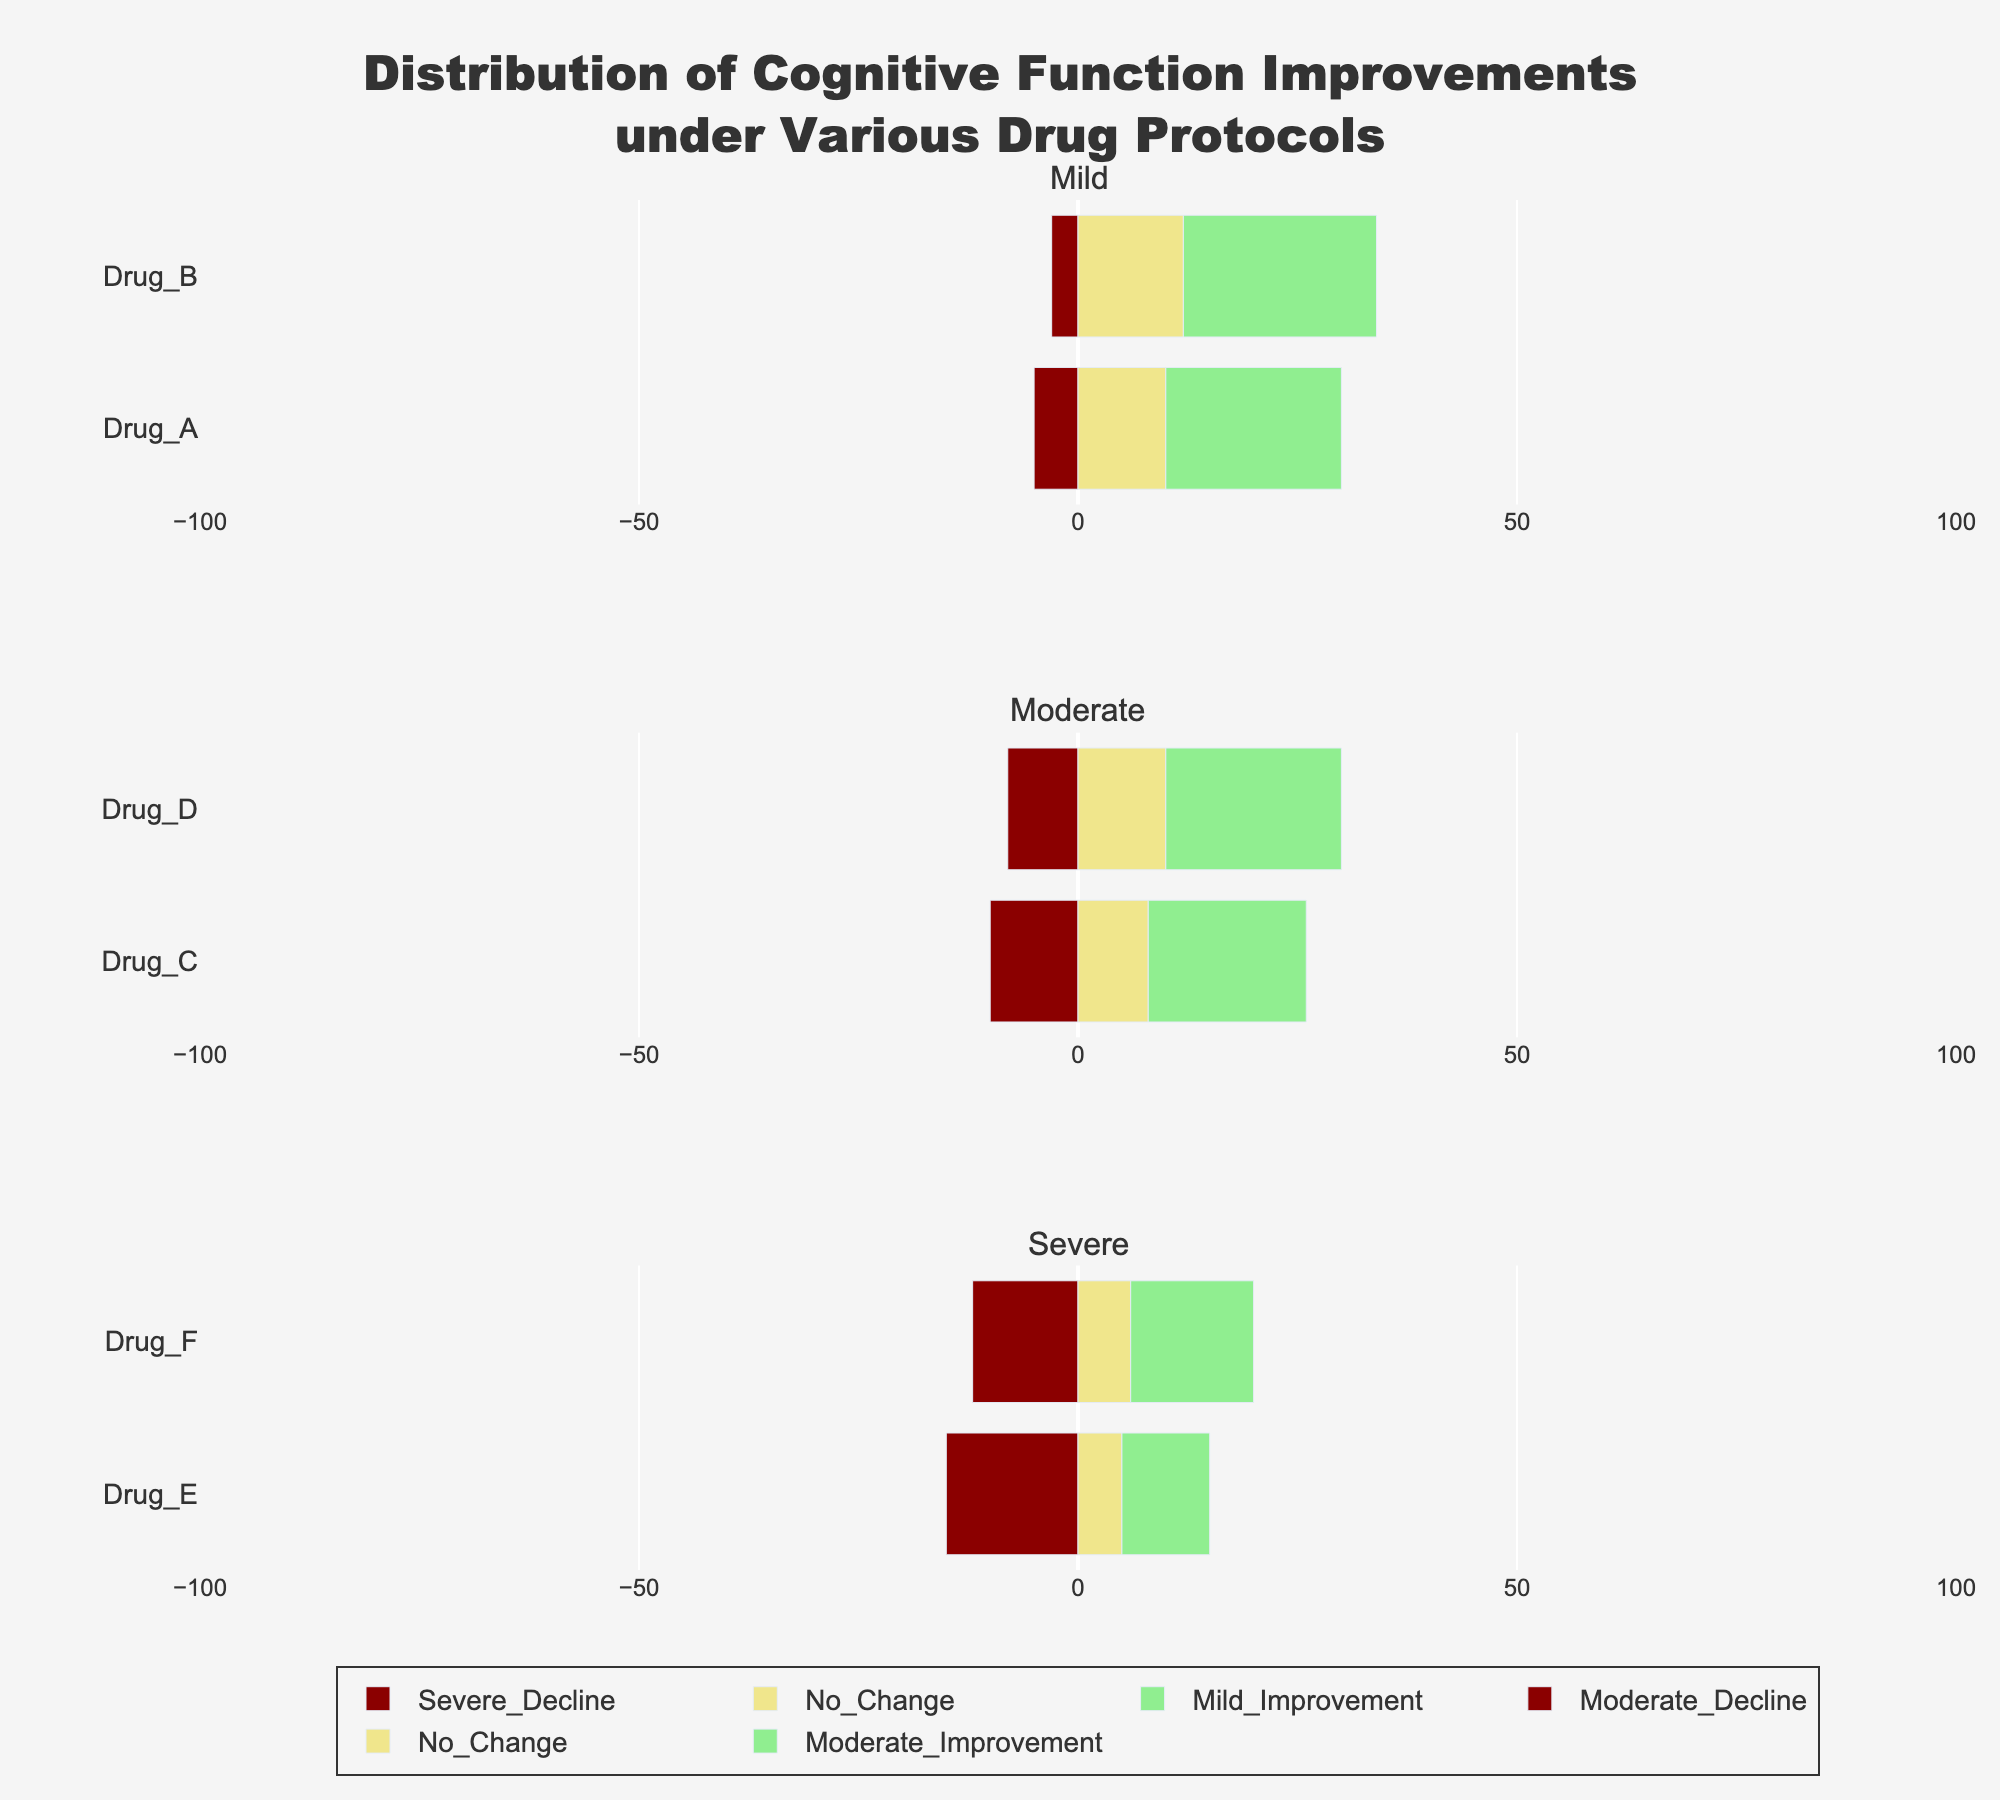Which drug protocol shows the greatest proportion of cognitive function severe improvement for patients with a severe initial condition severity? Look at the section labeled "Severe" and identify the bar with the tallest green segment representing severe improvement. Drug E in the Severe category has the largest green segment indicating severe improvement.
Answer: Drug E Which drug protocol shows the least severe decline for patients with a mild initial condition severity? Look at the section labeled "Mild" and find the protocol with the smallest red segment representing severe decline. Drug B in the Mild category has the smallest red segment, indicating the least severe decline.
Answer: Drug B Compare the total decline for Drug C and Drug D in the moderate initial condition severity category. Which one is higher? Add up the severe decline, moderate decline, and mild decline segments for both Drug C and Drug D in the Moderate category. Drug C has a total decline of 45 (10 + 15 + 20), and Drug D has a total decline of 38 (8 + 12 + 18). Drug C has a higher total decline.
Answer: Drug C What is the sum of mild improvement percentages across all drug protocols? Sum the mild improvement values from each drug protocol: 20 (Drug_A) + 22 (Drug_B) + 18 (Drug_C) + 20 (Drug_D) + 10 (Drug_E) + 14 (Drug_F). The total is 104.
Answer: 104 Which initial condition severity group shows the largest overall no change proportion? Look at the "No Change" segment (yellow) for all severity groups and compare the lengths. Observe that the severe condition severity group (Drug E and Drug F) has the smallest yellow segments. The largest "No Change" proportion is for the moderate condition severity group (Drugs C and D).
Answer: Moderate In the mild initial condition severity category, which drug protocol shows the highest overall improvement? Add the mild improvement, moderate improvement, and severe improvement segments for both Drug A and Drug B. Drug A has an overall improvement of 100 (20 + 30 + 50), and Drug B has 100 (22 + 33 + 45). Both have the same total, but Drug A shows a higher representation of severe improvement.
Answer: Drug A Considering the moderate condition severity category, what is the difference in the proportion of severe improvement between Drug C and Drug D? Find the difference between the severe improvement segments of Drug C and Drug D. Drug C has 54%, and Drug D has 42%, resulting in a difference of 12%.
Answer: 12% Is there any drug protocol that does not lead to any severe decline across any initial condition severity group? Check all the bars for each drug protocol across all severity groups for a lack of red segments representing severe decline. All protocols show some degree of severe decline, so no drug protocol completely lacks severe decline.
Answer: No 